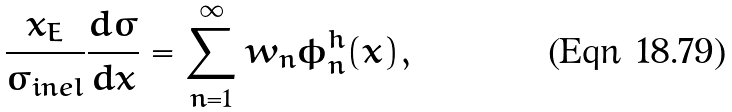<formula> <loc_0><loc_0><loc_500><loc_500>\frac { x _ { E } } { \sigma _ { i n e l } } \frac { d \sigma } { d x } = \sum _ { n = 1 } ^ { \infty } w _ { n } \phi _ { n } ^ { h } ( x ) ,</formula> 